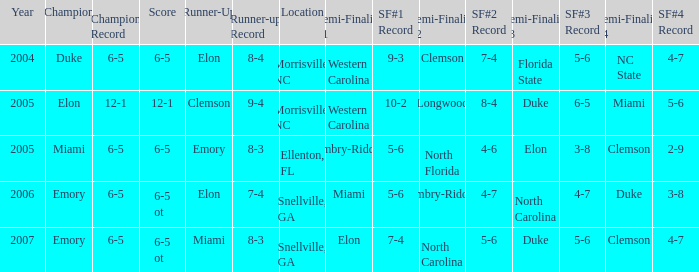Which team was the second semi finalist in 2007? North Carolina. 